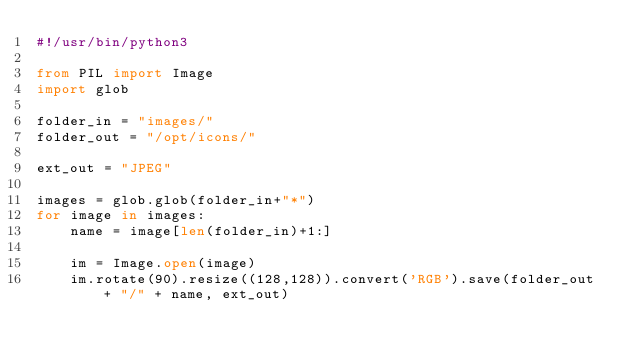<code> <loc_0><loc_0><loc_500><loc_500><_Python_>#!/usr/bin/python3

from PIL import Image
import glob

folder_in = "images/"
folder_out = "/opt/icons/"

ext_out = "JPEG"

images = glob.glob(folder_in+"*")
for image in images:
    name = image[len(folder_in)+1:]

    im = Image.open(image)
    im.rotate(90).resize((128,128)).convert('RGB').save(folder_out + "/" + name, ext_out)

</code> 